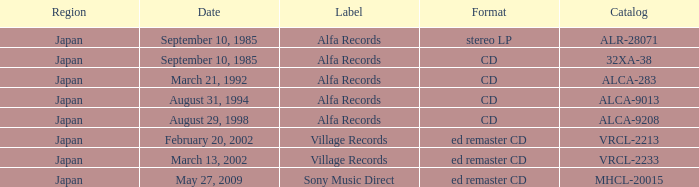What label is identified as alca-9013 in the catalog? Alfa Records. 